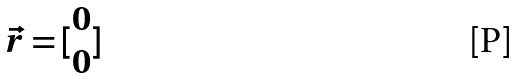<formula> <loc_0><loc_0><loc_500><loc_500>\vec { r } = [ \begin{matrix} 0 \\ 0 \end{matrix} ]</formula> 